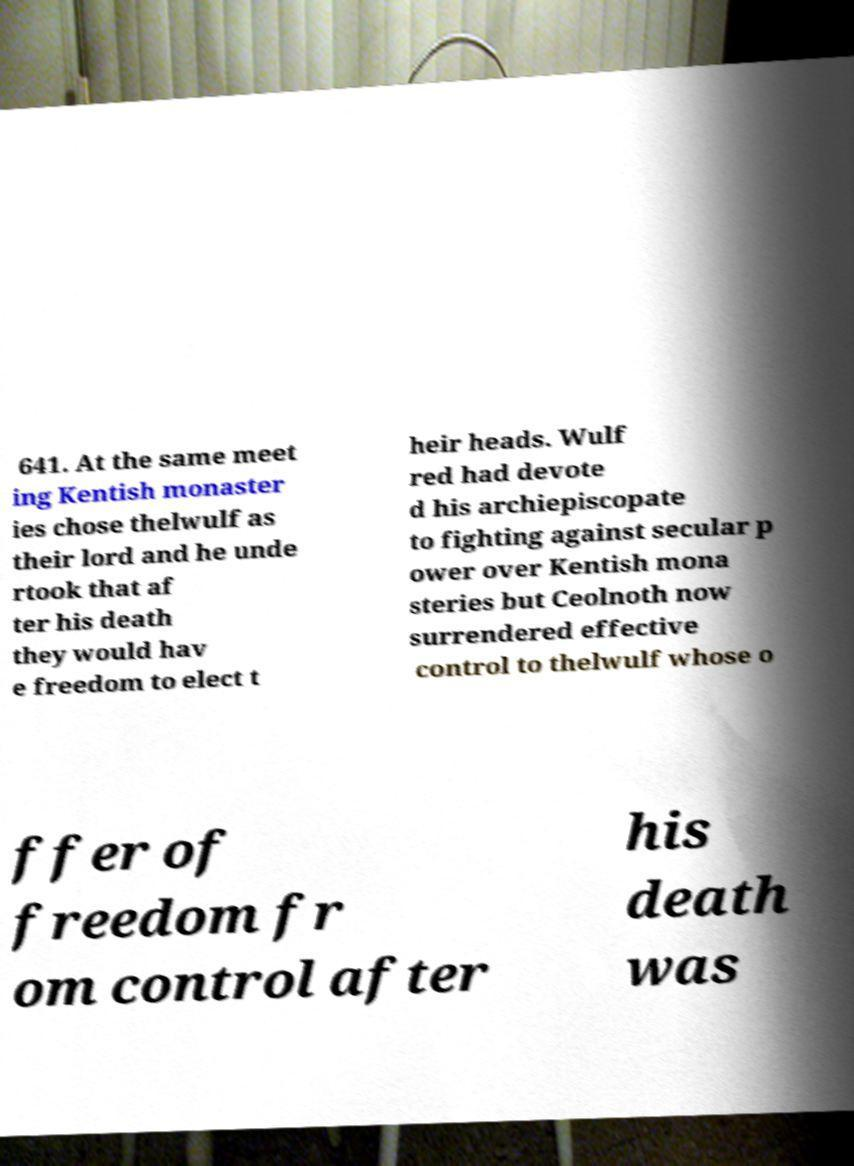Please read and relay the text visible in this image. What does it say? 641. At the same meet ing Kentish monaster ies chose thelwulf as their lord and he unde rtook that af ter his death they would hav e freedom to elect t heir heads. Wulf red had devote d his archiepiscopate to fighting against secular p ower over Kentish mona steries but Ceolnoth now surrendered effective control to thelwulf whose o ffer of freedom fr om control after his death was 